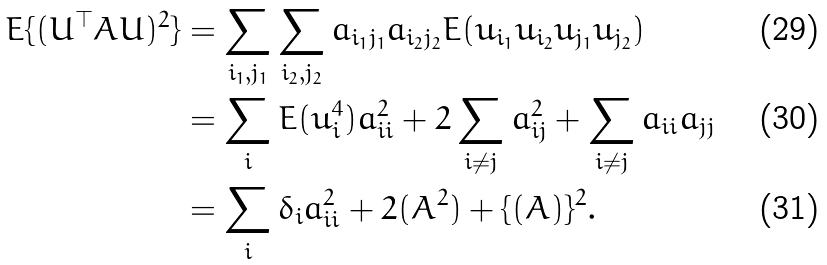<formula> <loc_0><loc_0><loc_500><loc_500>E \{ ( U ^ { \top } A U ) ^ { 2 } \} & = \sum _ { i _ { 1 } , j _ { 1 } } \sum _ { i _ { 2 } , j _ { 2 } } a _ { i _ { 1 } j _ { 1 } } a _ { i _ { 2 } j _ { 2 } } E ( u _ { i _ { 1 } } u _ { i _ { 2 } } u _ { j _ { 1 } } u _ { j _ { 2 } } ) \\ & = \sum _ { i } E ( u _ { i } ^ { 4 } ) a _ { i i } ^ { 2 } + 2 \sum _ { i \neq j } a _ { i j } ^ { 2 } + \sum _ { i \neq j } a _ { i i } a _ { j j } \\ & = \sum _ { i } \delta _ { i } a _ { i i } ^ { 2 } + 2 ( A ^ { 2 } ) + \{ ( A ) \} ^ { 2 } .</formula> 